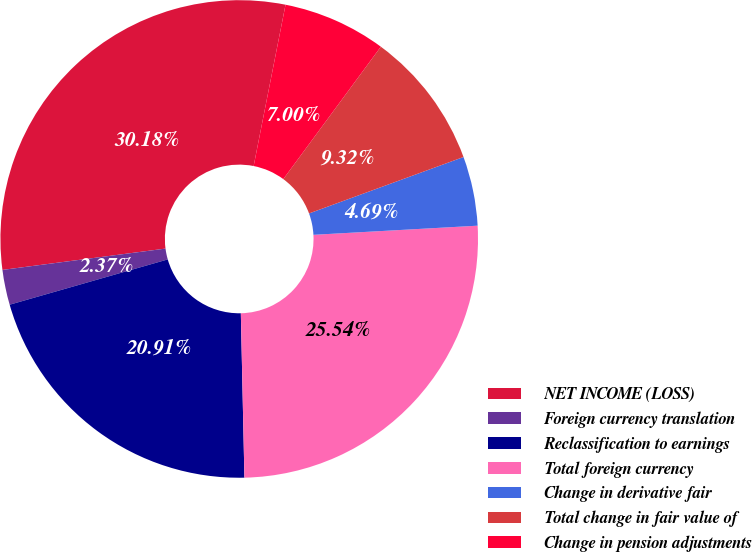Convert chart. <chart><loc_0><loc_0><loc_500><loc_500><pie_chart><fcel>NET INCOME (LOSS)<fcel>Foreign currency translation<fcel>Reclassification to earnings<fcel>Total foreign currency<fcel>Change in derivative fair<fcel>Total change in fair value of<fcel>Change in pension adjustments<nl><fcel>30.18%<fcel>2.37%<fcel>20.91%<fcel>25.54%<fcel>4.69%<fcel>9.32%<fcel>7.0%<nl></chart> 